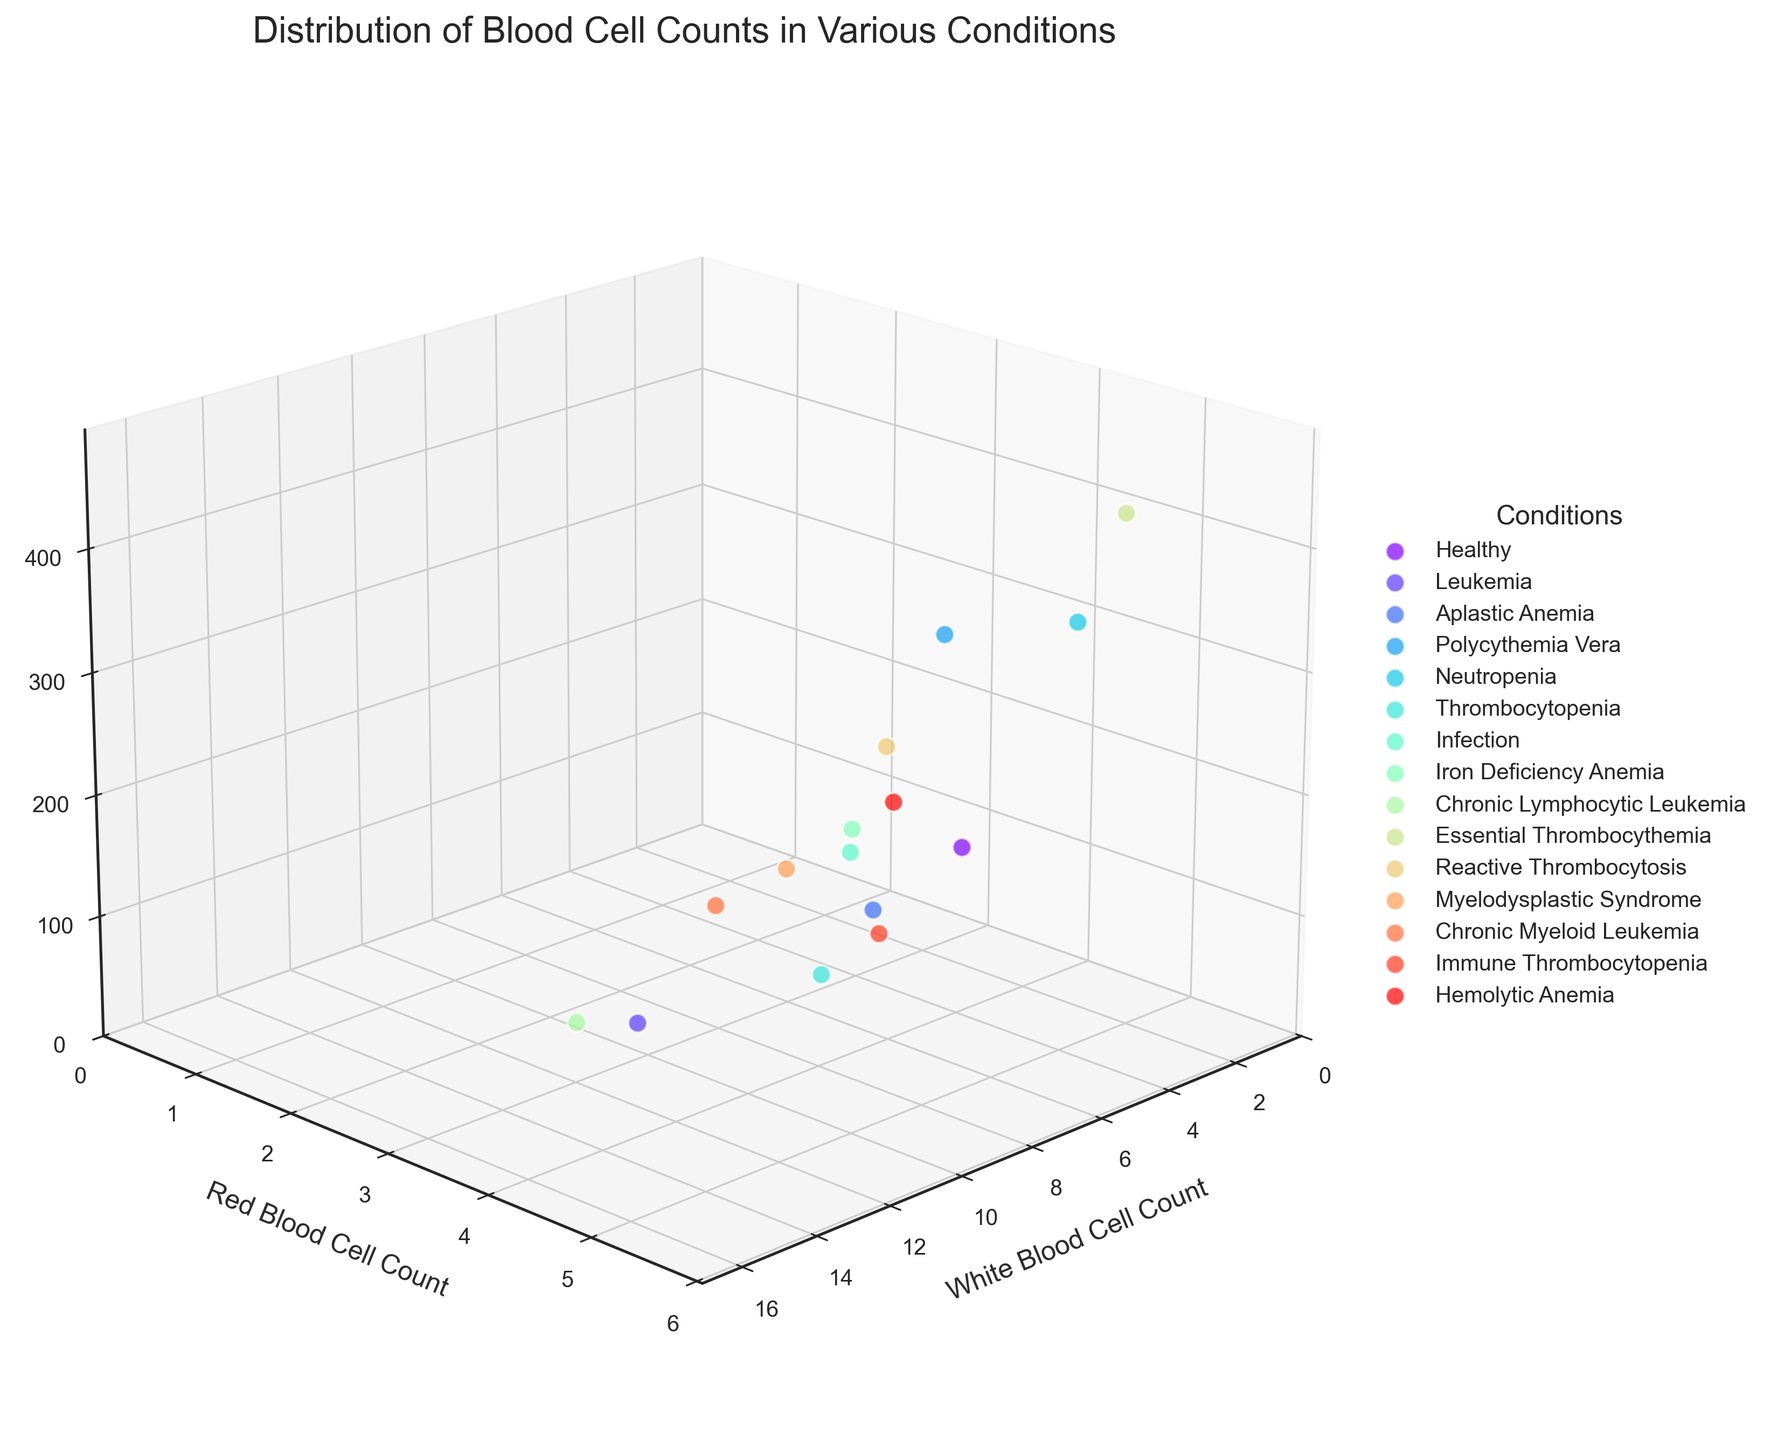What are the three axes labels in the plot? The plot shows three axes, with each representing a type of blood cell count. The x-axis label is 'White Blood Cell Count', the y-axis label is 'Red Blood Cell Count', and the z-axis label is 'Platelet Count'.
Answer: 'White Blood Cell Count', 'Red Blood Cell Count', 'Platelet Count' How many unique blood disorders are represented in the plot? The legend shows the different blood disorders represented in the plot. By counting the legend entries, we can determine the number of unique blood disorders.
Answer: 14 Which blood disorder has the highest White Blood Cell count? By looking at the points on the x-axis and the associated labels in the legend, the disorder with the highest value is Chronic Lymphocytic Leukemia with a white blood cell count of 15.5.
Answer: Chronic Lymphocytic Leukemia How does the platelet count for Essential Thrombocythemia compare to that of Thrombocytopenia? By comparing the z-axis values for the conditions Essential Thrombocythemia and Thrombocytopenia, Essential Thrombocythemia has a platelet count of 450 whereas Thrombocytopenia has a platelet count of 25. Thus, Essential Thrombocythemia has much higher platelet count.
Answer: Higher What is the relationship between red blood cell count and white blood cell count for Neutropenia and Polycythemia Vera? Neutropenia has a white blood cell count of 2.1 and red blood cell count of 4.5. Polycythemia Vera has a white blood cell count of 7.8 and red blood cell count of 5.1. Polycythemia Vera has higher counts for both metrics compared to Neutropenia.
Answer: Polycythemia Vera has higher values for both Which blood disorder has the lowest Platelet count? By identifying the points with the lowest value on the z-axis and cross-referencing them with the legend, Aplastic Anemia has the lowest platelet count of 45.
Answer: Aplastic Anemia Are there any blood disorders that have higher than 10 for white blood cell count and also higher than 4 for red blood cell count? From the plot, we evaluate the conditions with white blood cell count values greater than 10 and cross-check their red blood cell counts. Chronic Lymphocytic Leukemia (15.5, 4.3) and Chronic Myeloid Leukemia (11.2, 4.1) meet these criteria.
Answer: Yes, Chronic Lymphocytic Leukemia and Chronic Myeloid Leukemia What is the range of platelet counts observed in the plot? The smallest and largest z-axis values are identified to be 25 (Thrombocytopenia) and 450 (Essential Thrombocythemia). The range is calculated as 450 - 25 = 425.
Answer: 425 Which condition appears to have balanced counts across all three types of cells (WBC, RBC, Platelets)? By visually inspecting the plot for conditions with relatively moderate and balanced values across all three axes, Hemolytic Anemia appears balanced with values close in the middle ranges: WBC 7.1, RBC 4.4, and Platelets 220.
Answer: Hemolytic Anemia 